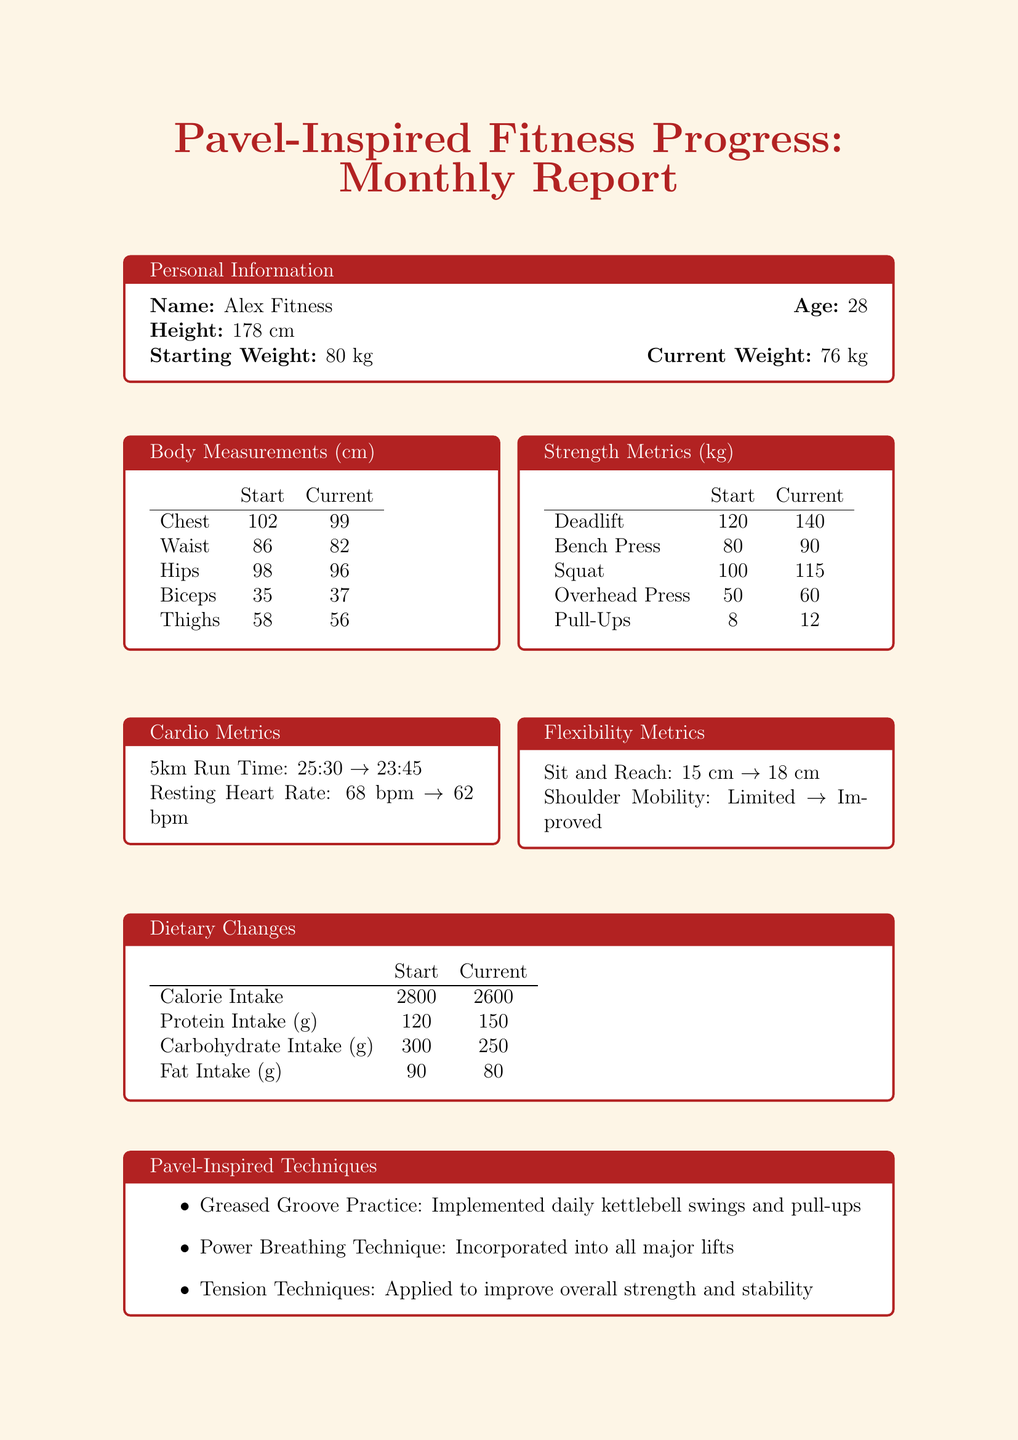What is the current weight of Alex Fitness? The current weight is mentioned in the personal information section of the document.
Answer: 76 kg How much did the deadlift increase? The increase in deadlift is calculated by subtracting the starting weight from the current weight.
Answer: 20 kg What is the current protein intake? The current protein intake is listed under dietary changes in the document.
Answer: 150 What was the improvement in the 5km run time? The improvement in run time is calculated by finding the difference between the starting and current times.
Answer: 1:45 What is the starting waist measurement? The starting waist measurement is noted in the body measurements section.
Answer: 86 Which Pavel-inspired technique involves daily kettlebell swings? This technique is mentioned in the techniques section of the document.
Answer: Greased Groove Practice How many consecutive pull-ups are aimed to be achieved as an upcoming goal? This information is included in the list of upcoming goals.
Answer: 15 What was the combined fat intake at the start? The starting fat intake is detailed in the dietary changes and is a simple number.
Answer: 90 